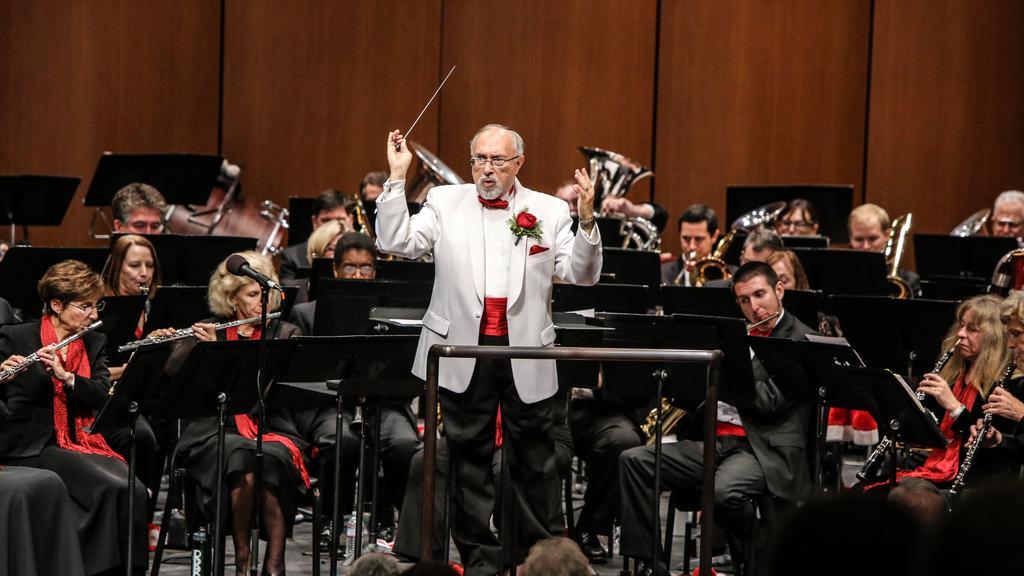How would you summarize this image in a sentence or two? In the picture I can see an old man wearing white color blazer is standing here on the floor by holding a stick in his hand. In the background, we can see a few more people wearing black color dresses are playing musical instruments and sitting on the chairs and we can see the wooden wall. 